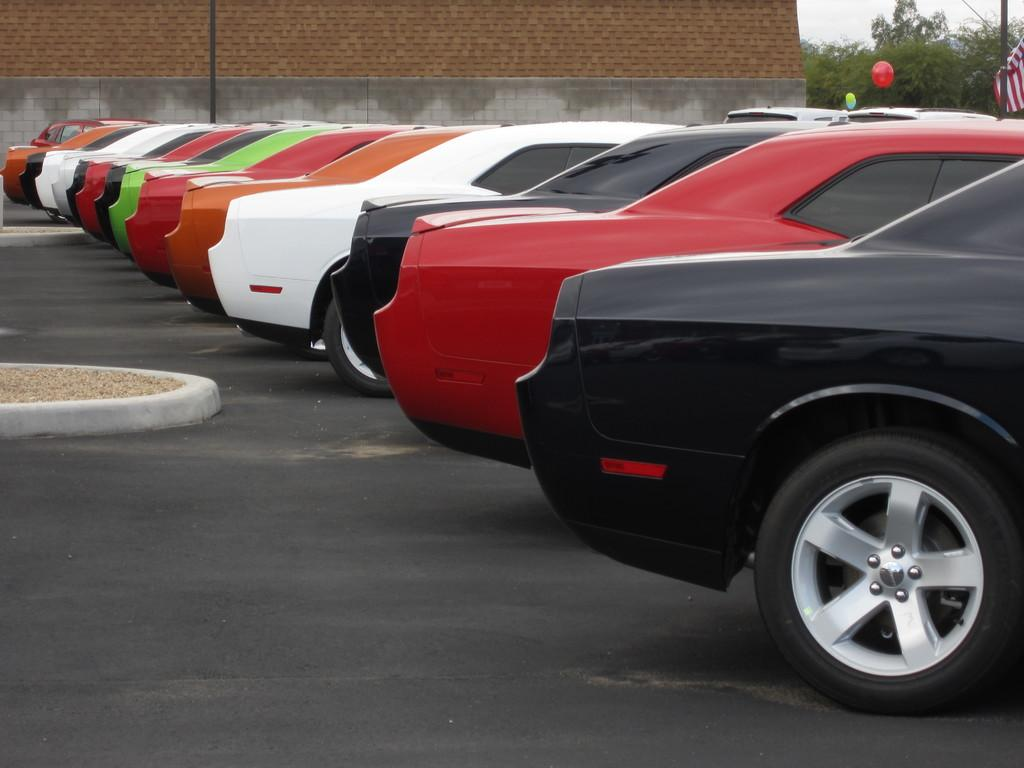What can be seen on the road in the image? There are fleets of cars on the road in the image. What structures can be seen in the background of the image? There is a wall fence, a pole, trees, a flag, and a wall visible in the background. What part of the natural environment is visible in the image? The sky is visible in the background of the image. Can you determine the time of day the image was taken? The image is likely taken during the day, as the sky is visible and there is no indication of darkness. What type of book is the car reading in the image? There are no cars reading books in the image; it features fleets of cars on the road. How much debt does the flag owe in the image? There is no mention of debt in the image, and the flag is not associated with any financial obligations. 